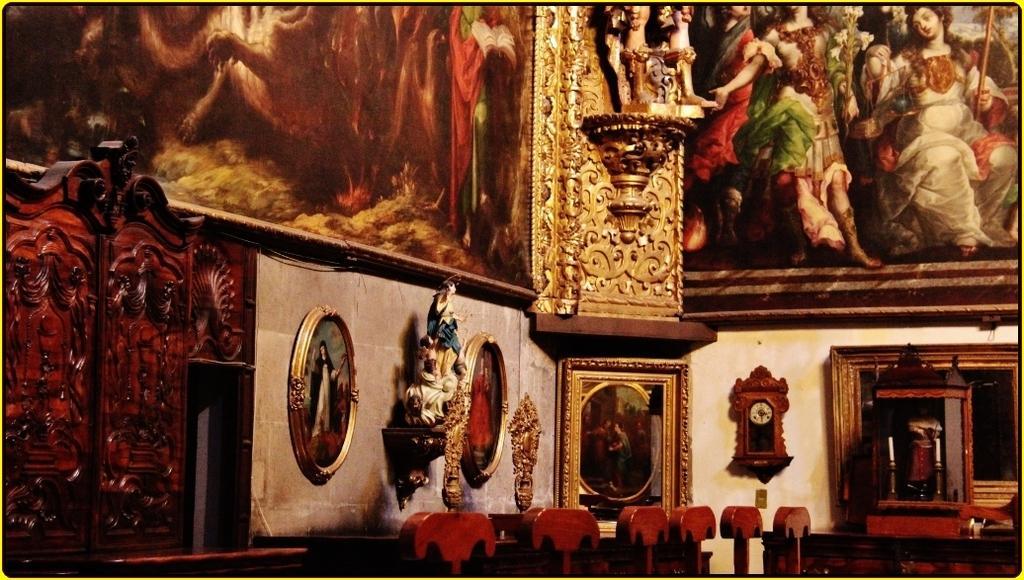Can you describe this image briefly? In the picture we can see a wall with paintings, sculptures with wooden frame and besides it we can see some wooden sculptures. 